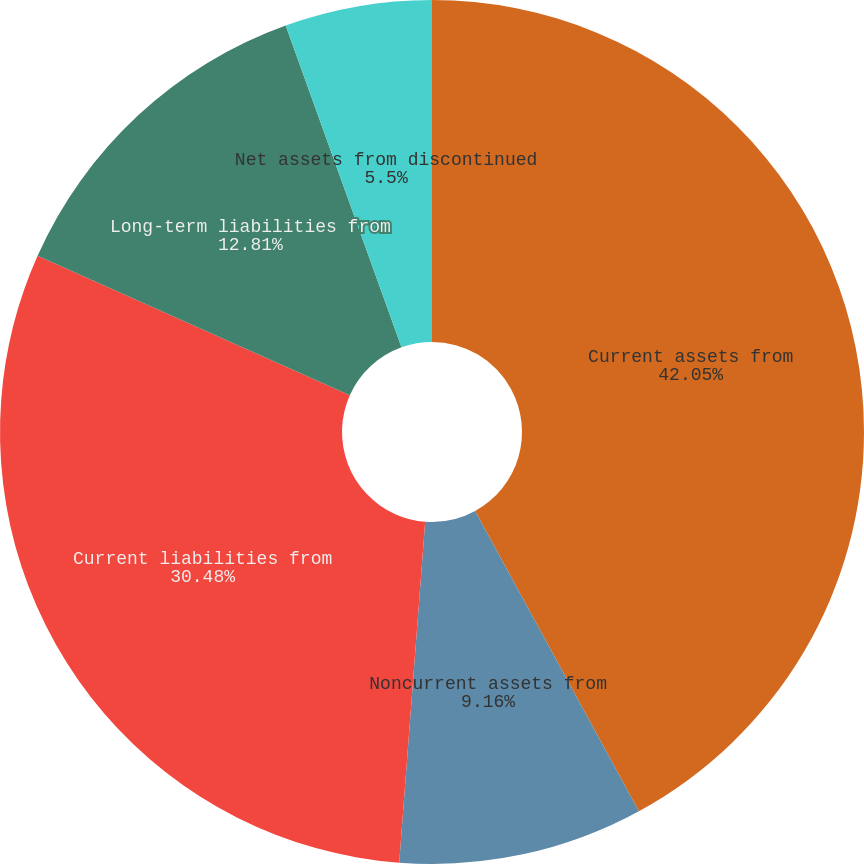<chart> <loc_0><loc_0><loc_500><loc_500><pie_chart><fcel>Current assets from<fcel>Noncurrent assets from<fcel>Current liabilities from<fcel>Long-term liabilities from<fcel>Net assets from discontinued<nl><fcel>42.05%<fcel>9.16%<fcel>30.48%<fcel>12.81%<fcel>5.5%<nl></chart> 